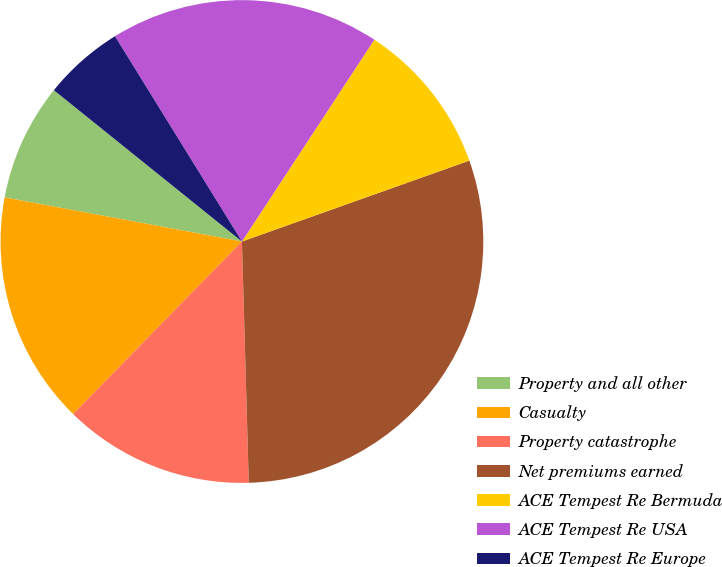Convert chart to OTSL. <chart><loc_0><loc_0><loc_500><loc_500><pie_chart><fcel>Property and all other<fcel>Casualty<fcel>Property catastrophe<fcel>Net premiums earned<fcel>ACE Tempest Re Bermuda<fcel>ACE Tempest Re USA<fcel>ACE Tempest Re Europe<nl><fcel>7.86%<fcel>15.6%<fcel>12.78%<fcel>29.99%<fcel>10.32%<fcel>18.06%<fcel>5.4%<nl></chart> 